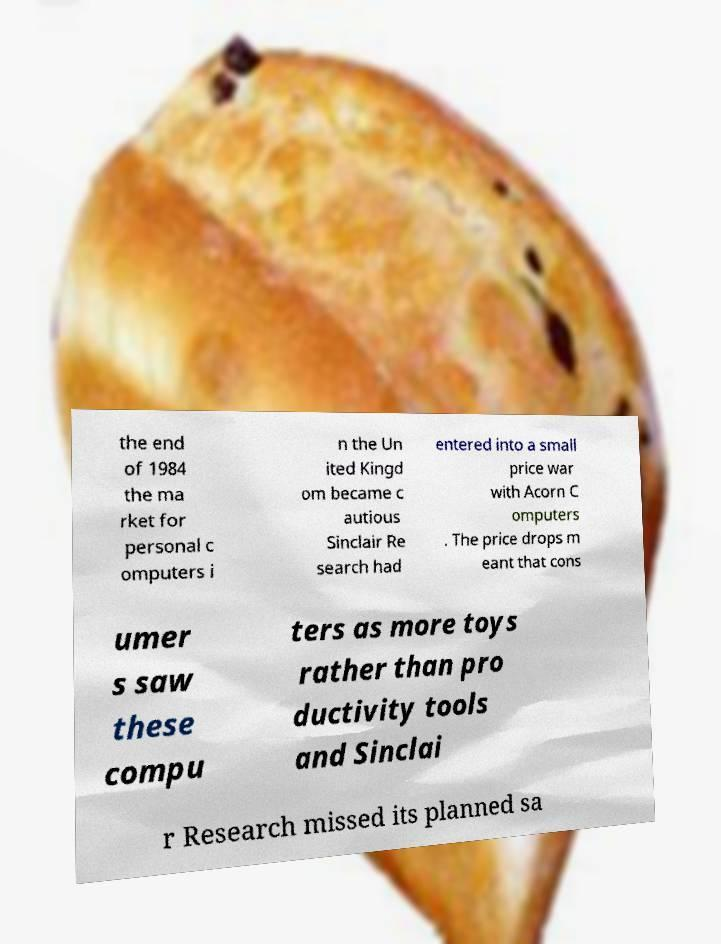Could you extract and type out the text from this image? the end of 1984 the ma rket for personal c omputers i n the Un ited Kingd om became c autious Sinclair Re search had entered into a small price war with Acorn C omputers . The price drops m eant that cons umer s saw these compu ters as more toys rather than pro ductivity tools and Sinclai r Research missed its planned sa 